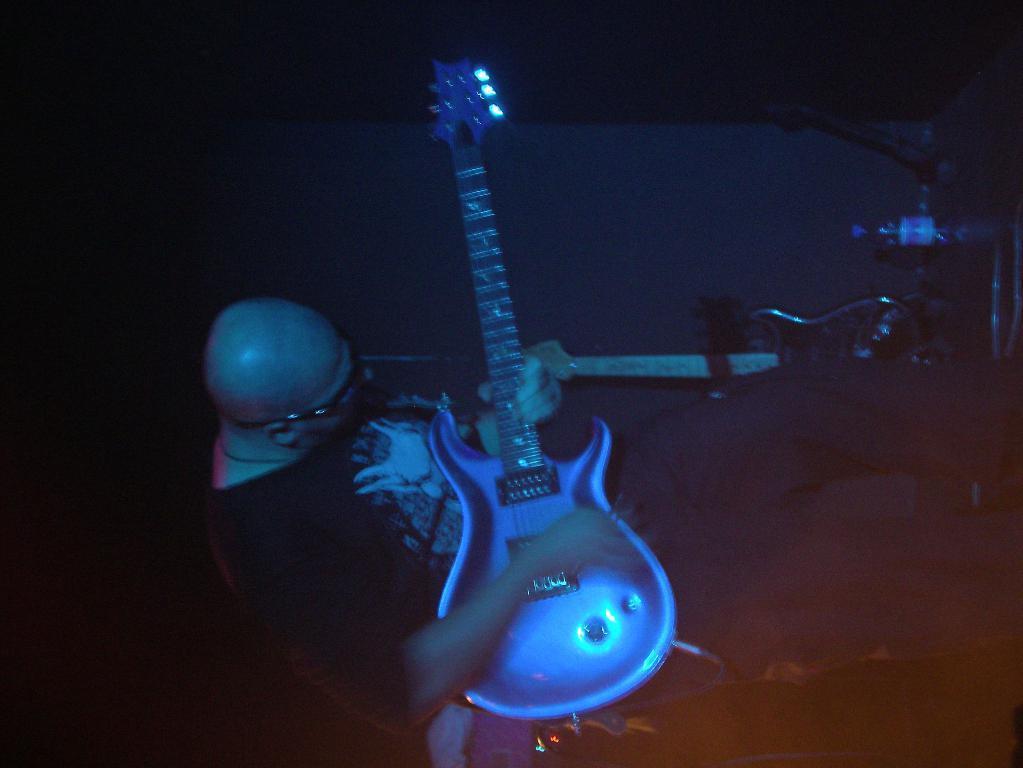Please provide a concise description of this image. In this picture we can see a person holding a guitar in his hand. We can see another guitar and a few objects in the background. There is a dark view in the background. 